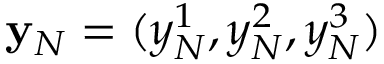Convert formula to latex. <formula><loc_0><loc_0><loc_500><loc_500>{ y } _ { N } = ( y _ { N } ^ { 1 } , y _ { N } ^ { 2 } , y _ { N } ^ { 3 } )</formula> 